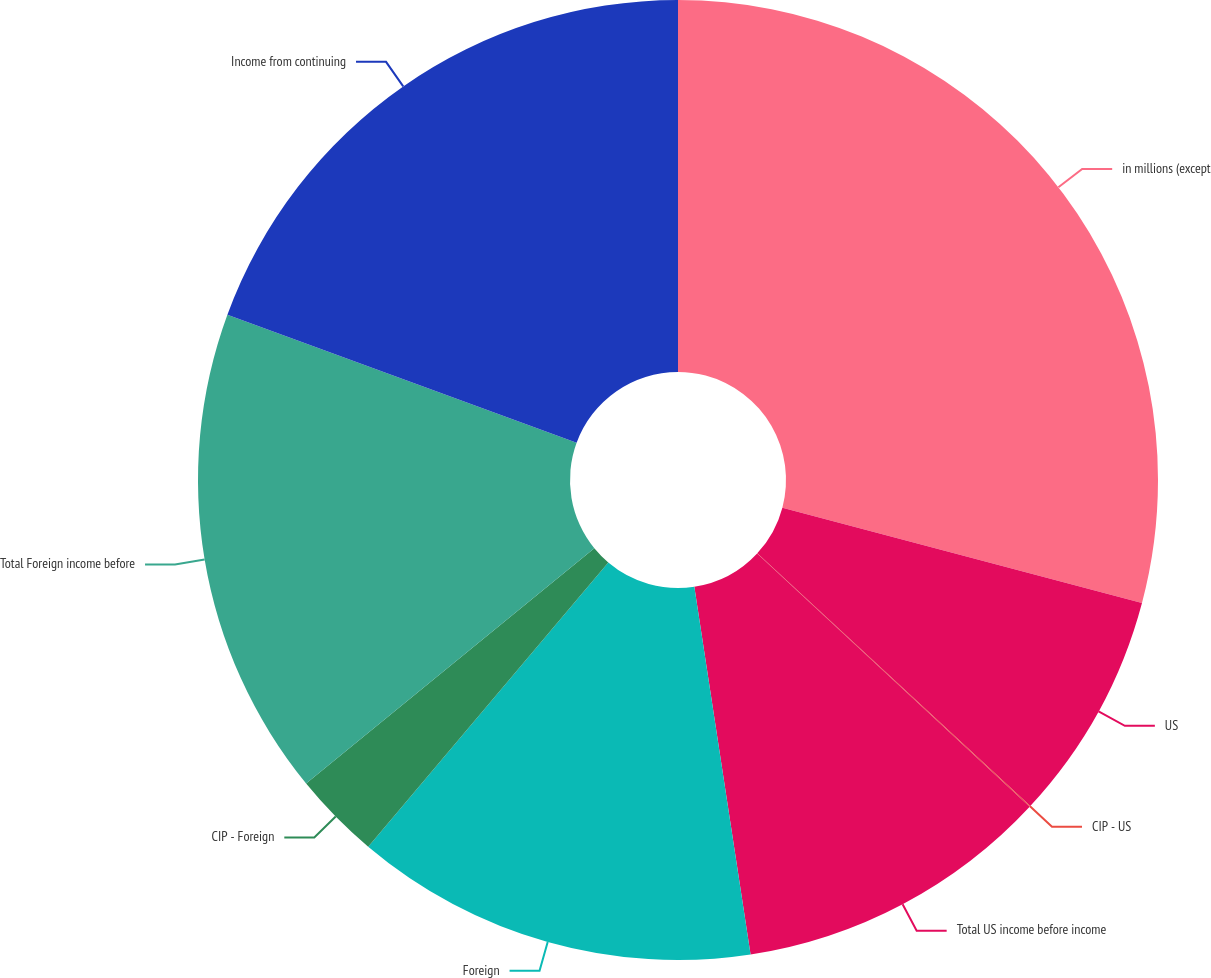<chart> <loc_0><loc_0><loc_500><loc_500><pie_chart><fcel>in millions (except<fcel>US<fcel>CIP - US<fcel>Total US income before income<fcel>Foreign<fcel>CIP - Foreign<fcel>Total Foreign income before<fcel>Income from continuing<nl><fcel>29.12%<fcel>7.76%<fcel>0.03%<fcel>10.67%<fcel>13.58%<fcel>2.94%<fcel>16.49%<fcel>19.4%<nl></chart> 